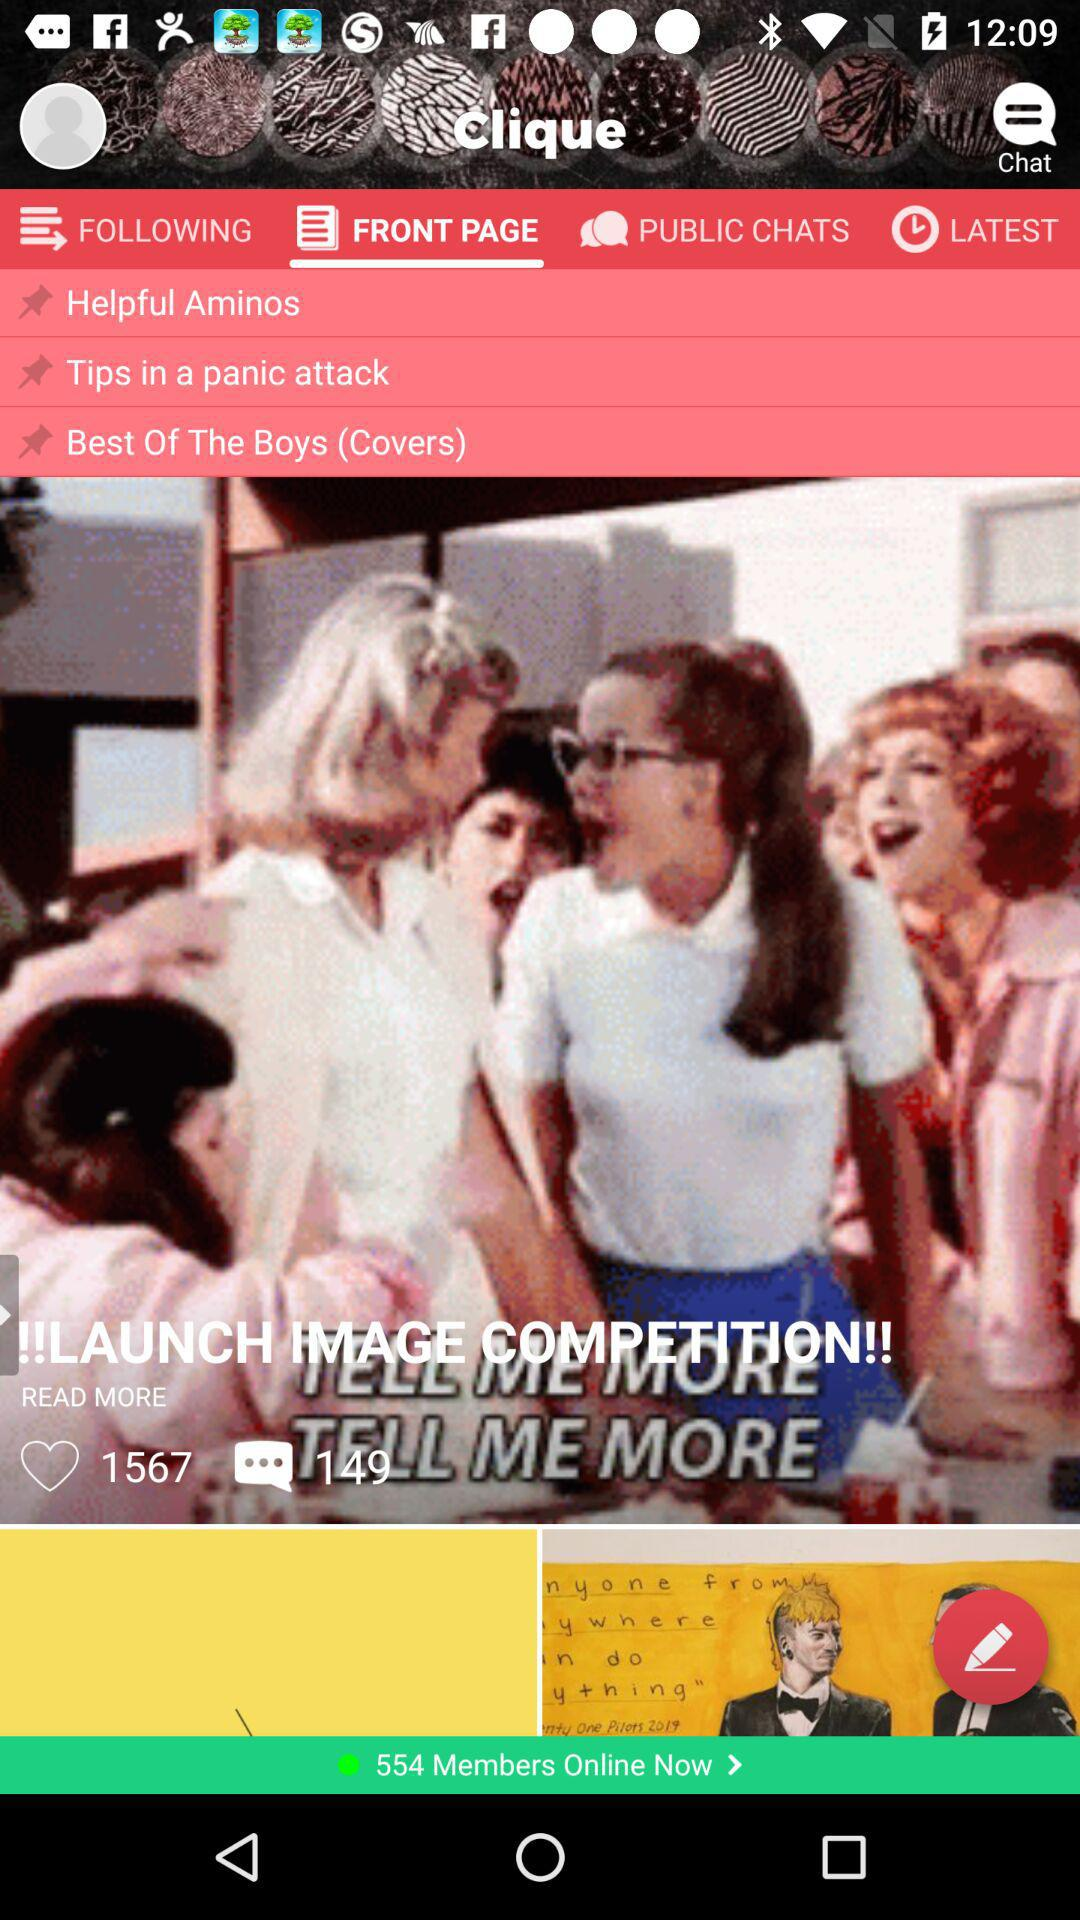What is the name of the application? The name of the application is "Clique". 